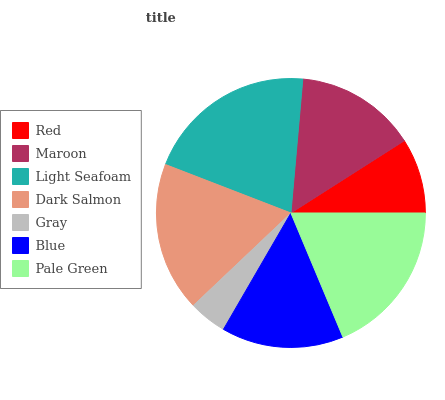Is Gray the minimum?
Answer yes or no. Yes. Is Light Seafoam the maximum?
Answer yes or no. Yes. Is Maroon the minimum?
Answer yes or no. No. Is Maroon the maximum?
Answer yes or no. No. Is Maroon greater than Red?
Answer yes or no. Yes. Is Red less than Maroon?
Answer yes or no. Yes. Is Red greater than Maroon?
Answer yes or no. No. Is Maroon less than Red?
Answer yes or no. No. Is Blue the high median?
Answer yes or no. Yes. Is Blue the low median?
Answer yes or no. Yes. Is Pale Green the high median?
Answer yes or no. No. Is Dark Salmon the low median?
Answer yes or no. No. 